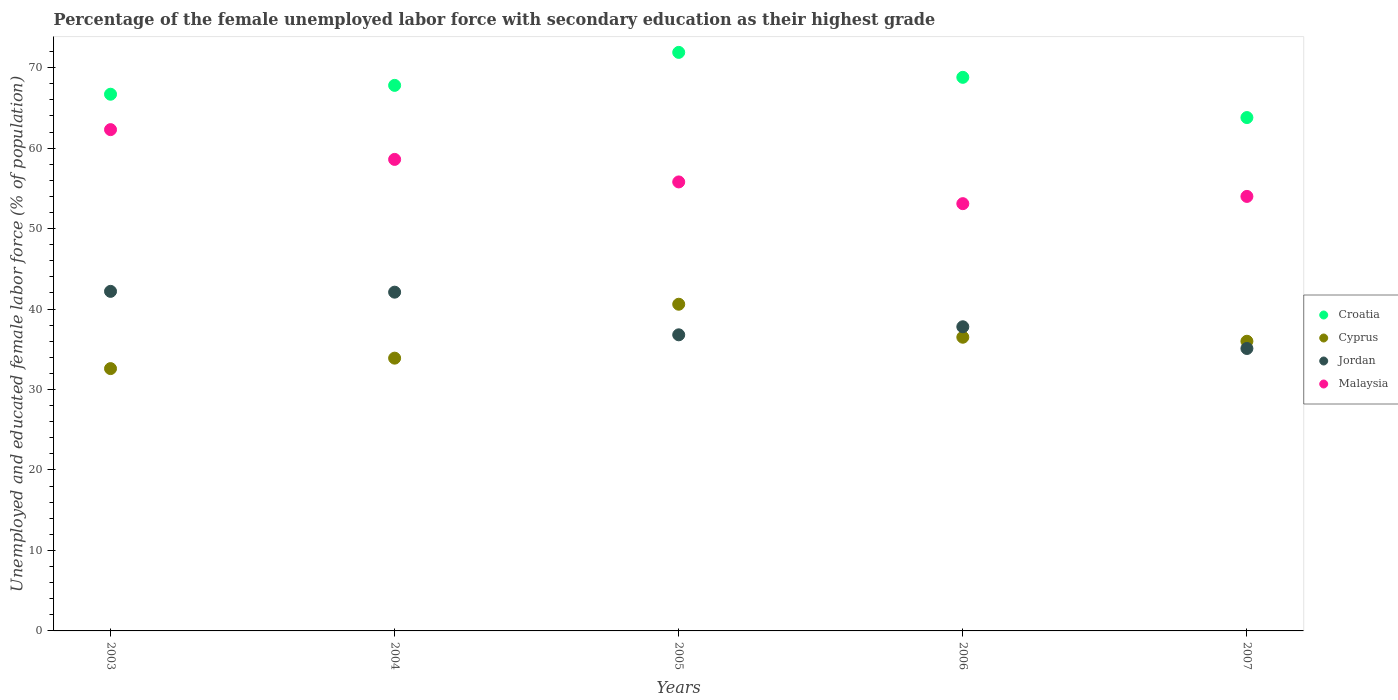Is the number of dotlines equal to the number of legend labels?
Provide a succinct answer. Yes. What is the percentage of the unemployed female labor force with secondary education in Cyprus in 2007?
Provide a succinct answer. 36. Across all years, what is the maximum percentage of the unemployed female labor force with secondary education in Cyprus?
Your response must be concise. 40.6. Across all years, what is the minimum percentage of the unemployed female labor force with secondary education in Jordan?
Give a very brief answer. 35.1. In which year was the percentage of the unemployed female labor force with secondary education in Malaysia minimum?
Provide a succinct answer. 2006. What is the total percentage of the unemployed female labor force with secondary education in Malaysia in the graph?
Provide a succinct answer. 283.8. What is the difference between the percentage of the unemployed female labor force with secondary education in Croatia in 2004 and that in 2005?
Your answer should be very brief. -4.1. What is the difference between the percentage of the unemployed female labor force with secondary education in Malaysia in 2006 and the percentage of the unemployed female labor force with secondary education in Jordan in 2005?
Provide a succinct answer. 16.3. What is the average percentage of the unemployed female labor force with secondary education in Malaysia per year?
Offer a very short reply. 56.76. In the year 2004, what is the difference between the percentage of the unemployed female labor force with secondary education in Malaysia and percentage of the unemployed female labor force with secondary education in Croatia?
Offer a terse response. -9.2. What is the ratio of the percentage of the unemployed female labor force with secondary education in Cyprus in 2003 to that in 2005?
Offer a terse response. 0.8. What is the difference between the highest and the second highest percentage of the unemployed female labor force with secondary education in Cyprus?
Make the answer very short. 4.1. What is the difference between the highest and the lowest percentage of the unemployed female labor force with secondary education in Jordan?
Provide a short and direct response. 7.1. In how many years, is the percentage of the unemployed female labor force with secondary education in Malaysia greater than the average percentage of the unemployed female labor force with secondary education in Malaysia taken over all years?
Your answer should be very brief. 2. Is the sum of the percentage of the unemployed female labor force with secondary education in Cyprus in 2003 and 2005 greater than the maximum percentage of the unemployed female labor force with secondary education in Croatia across all years?
Offer a terse response. Yes. Is it the case that in every year, the sum of the percentage of the unemployed female labor force with secondary education in Jordan and percentage of the unemployed female labor force with secondary education in Malaysia  is greater than the sum of percentage of the unemployed female labor force with secondary education in Cyprus and percentage of the unemployed female labor force with secondary education in Croatia?
Your answer should be compact. No. Is it the case that in every year, the sum of the percentage of the unemployed female labor force with secondary education in Malaysia and percentage of the unemployed female labor force with secondary education in Cyprus  is greater than the percentage of the unemployed female labor force with secondary education in Croatia?
Offer a terse response. Yes. Does the percentage of the unemployed female labor force with secondary education in Croatia monotonically increase over the years?
Ensure brevity in your answer.  No. Is the percentage of the unemployed female labor force with secondary education in Jordan strictly greater than the percentage of the unemployed female labor force with secondary education in Malaysia over the years?
Your response must be concise. No. Is the percentage of the unemployed female labor force with secondary education in Malaysia strictly less than the percentage of the unemployed female labor force with secondary education in Cyprus over the years?
Offer a very short reply. No. How many dotlines are there?
Offer a very short reply. 4. What is the difference between two consecutive major ticks on the Y-axis?
Your answer should be compact. 10. Does the graph contain any zero values?
Offer a very short reply. No. Does the graph contain grids?
Provide a short and direct response. No. Where does the legend appear in the graph?
Give a very brief answer. Center right. How are the legend labels stacked?
Offer a very short reply. Vertical. What is the title of the graph?
Ensure brevity in your answer.  Percentage of the female unemployed labor force with secondary education as their highest grade. What is the label or title of the X-axis?
Ensure brevity in your answer.  Years. What is the label or title of the Y-axis?
Ensure brevity in your answer.  Unemployed and educated female labor force (% of population). What is the Unemployed and educated female labor force (% of population) in Croatia in 2003?
Your answer should be very brief. 66.7. What is the Unemployed and educated female labor force (% of population) of Cyprus in 2003?
Provide a short and direct response. 32.6. What is the Unemployed and educated female labor force (% of population) of Jordan in 2003?
Offer a terse response. 42.2. What is the Unemployed and educated female labor force (% of population) of Malaysia in 2003?
Offer a terse response. 62.3. What is the Unemployed and educated female labor force (% of population) in Croatia in 2004?
Your answer should be very brief. 67.8. What is the Unemployed and educated female labor force (% of population) in Cyprus in 2004?
Your answer should be compact. 33.9. What is the Unemployed and educated female labor force (% of population) in Jordan in 2004?
Your response must be concise. 42.1. What is the Unemployed and educated female labor force (% of population) of Malaysia in 2004?
Offer a very short reply. 58.6. What is the Unemployed and educated female labor force (% of population) of Croatia in 2005?
Ensure brevity in your answer.  71.9. What is the Unemployed and educated female labor force (% of population) in Cyprus in 2005?
Your answer should be compact. 40.6. What is the Unemployed and educated female labor force (% of population) of Jordan in 2005?
Offer a terse response. 36.8. What is the Unemployed and educated female labor force (% of population) of Malaysia in 2005?
Give a very brief answer. 55.8. What is the Unemployed and educated female labor force (% of population) in Croatia in 2006?
Your answer should be compact. 68.8. What is the Unemployed and educated female labor force (% of population) of Cyprus in 2006?
Make the answer very short. 36.5. What is the Unemployed and educated female labor force (% of population) of Jordan in 2006?
Offer a very short reply. 37.8. What is the Unemployed and educated female labor force (% of population) of Malaysia in 2006?
Ensure brevity in your answer.  53.1. What is the Unemployed and educated female labor force (% of population) of Croatia in 2007?
Ensure brevity in your answer.  63.8. What is the Unemployed and educated female labor force (% of population) in Cyprus in 2007?
Provide a succinct answer. 36. What is the Unemployed and educated female labor force (% of population) in Jordan in 2007?
Provide a succinct answer. 35.1. Across all years, what is the maximum Unemployed and educated female labor force (% of population) of Croatia?
Give a very brief answer. 71.9. Across all years, what is the maximum Unemployed and educated female labor force (% of population) of Cyprus?
Offer a terse response. 40.6. Across all years, what is the maximum Unemployed and educated female labor force (% of population) of Jordan?
Provide a short and direct response. 42.2. Across all years, what is the maximum Unemployed and educated female labor force (% of population) of Malaysia?
Your response must be concise. 62.3. Across all years, what is the minimum Unemployed and educated female labor force (% of population) in Croatia?
Make the answer very short. 63.8. Across all years, what is the minimum Unemployed and educated female labor force (% of population) in Cyprus?
Give a very brief answer. 32.6. Across all years, what is the minimum Unemployed and educated female labor force (% of population) of Jordan?
Ensure brevity in your answer.  35.1. Across all years, what is the minimum Unemployed and educated female labor force (% of population) in Malaysia?
Offer a very short reply. 53.1. What is the total Unemployed and educated female labor force (% of population) in Croatia in the graph?
Provide a succinct answer. 339. What is the total Unemployed and educated female labor force (% of population) of Cyprus in the graph?
Provide a short and direct response. 179.6. What is the total Unemployed and educated female labor force (% of population) of Jordan in the graph?
Keep it short and to the point. 194. What is the total Unemployed and educated female labor force (% of population) in Malaysia in the graph?
Ensure brevity in your answer.  283.8. What is the difference between the Unemployed and educated female labor force (% of population) of Cyprus in 2003 and that in 2004?
Your answer should be compact. -1.3. What is the difference between the Unemployed and educated female labor force (% of population) of Jordan in 2003 and that in 2004?
Give a very brief answer. 0.1. What is the difference between the Unemployed and educated female labor force (% of population) in Cyprus in 2003 and that in 2005?
Your response must be concise. -8. What is the difference between the Unemployed and educated female labor force (% of population) in Jordan in 2003 and that in 2005?
Make the answer very short. 5.4. What is the difference between the Unemployed and educated female labor force (% of population) in Malaysia in 2003 and that in 2005?
Keep it short and to the point. 6.5. What is the difference between the Unemployed and educated female labor force (% of population) of Cyprus in 2003 and that in 2006?
Your answer should be very brief. -3.9. What is the difference between the Unemployed and educated female labor force (% of population) in Jordan in 2003 and that in 2006?
Keep it short and to the point. 4.4. What is the difference between the Unemployed and educated female labor force (% of population) in Malaysia in 2003 and that in 2006?
Provide a short and direct response. 9.2. What is the difference between the Unemployed and educated female labor force (% of population) in Cyprus in 2003 and that in 2007?
Keep it short and to the point. -3.4. What is the difference between the Unemployed and educated female labor force (% of population) in Cyprus in 2004 and that in 2005?
Offer a terse response. -6.7. What is the difference between the Unemployed and educated female labor force (% of population) of Jordan in 2004 and that in 2005?
Make the answer very short. 5.3. What is the difference between the Unemployed and educated female labor force (% of population) in Croatia in 2004 and that in 2006?
Ensure brevity in your answer.  -1. What is the difference between the Unemployed and educated female labor force (% of population) of Cyprus in 2004 and that in 2006?
Your answer should be very brief. -2.6. What is the difference between the Unemployed and educated female labor force (% of population) in Jordan in 2004 and that in 2006?
Ensure brevity in your answer.  4.3. What is the difference between the Unemployed and educated female labor force (% of population) in Jordan in 2004 and that in 2007?
Your answer should be very brief. 7. What is the difference between the Unemployed and educated female labor force (% of population) of Malaysia in 2004 and that in 2007?
Give a very brief answer. 4.6. What is the difference between the Unemployed and educated female labor force (% of population) in Croatia in 2005 and that in 2006?
Your response must be concise. 3.1. What is the difference between the Unemployed and educated female labor force (% of population) in Cyprus in 2005 and that in 2006?
Ensure brevity in your answer.  4.1. What is the difference between the Unemployed and educated female labor force (% of population) of Jordan in 2005 and that in 2006?
Keep it short and to the point. -1. What is the difference between the Unemployed and educated female labor force (% of population) in Croatia in 2005 and that in 2007?
Your answer should be compact. 8.1. What is the difference between the Unemployed and educated female labor force (% of population) of Cyprus in 2005 and that in 2007?
Give a very brief answer. 4.6. What is the difference between the Unemployed and educated female labor force (% of population) in Jordan in 2005 and that in 2007?
Offer a very short reply. 1.7. What is the difference between the Unemployed and educated female labor force (% of population) of Jordan in 2006 and that in 2007?
Provide a short and direct response. 2.7. What is the difference between the Unemployed and educated female labor force (% of population) in Croatia in 2003 and the Unemployed and educated female labor force (% of population) in Cyprus in 2004?
Provide a short and direct response. 32.8. What is the difference between the Unemployed and educated female labor force (% of population) of Croatia in 2003 and the Unemployed and educated female labor force (% of population) of Jordan in 2004?
Provide a succinct answer. 24.6. What is the difference between the Unemployed and educated female labor force (% of population) in Cyprus in 2003 and the Unemployed and educated female labor force (% of population) in Jordan in 2004?
Ensure brevity in your answer.  -9.5. What is the difference between the Unemployed and educated female labor force (% of population) in Cyprus in 2003 and the Unemployed and educated female labor force (% of population) in Malaysia in 2004?
Give a very brief answer. -26. What is the difference between the Unemployed and educated female labor force (% of population) of Jordan in 2003 and the Unemployed and educated female labor force (% of population) of Malaysia in 2004?
Ensure brevity in your answer.  -16.4. What is the difference between the Unemployed and educated female labor force (% of population) in Croatia in 2003 and the Unemployed and educated female labor force (% of population) in Cyprus in 2005?
Provide a short and direct response. 26.1. What is the difference between the Unemployed and educated female labor force (% of population) of Croatia in 2003 and the Unemployed and educated female labor force (% of population) of Jordan in 2005?
Provide a short and direct response. 29.9. What is the difference between the Unemployed and educated female labor force (% of population) of Cyprus in 2003 and the Unemployed and educated female labor force (% of population) of Malaysia in 2005?
Provide a succinct answer. -23.2. What is the difference between the Unemployed and educated female labor force (% of population) of Croatia in 2003 and the Unemployed and educated female labor force (% of population) of Cyprus in 2006?
Your answer should be compact. 30.2. What is the difference between the Unemployed and educated female labor force (% of population) in Croatia in 2003 and the Unemployed and educated female labor force (% of population) in Jordan in 2006?
Your answer should be compact. 28.9. What is the difference between the Unemployed and educated female labor force (% of population) of Cyprus in 2003 and the Unemployed and educated female labor force (% of population) of Jordan in 2006?
Give a very brief answer. -5.2. What is the difference between the Unemployed and educated female labor force (% of population) in Cyprus in 2003 and the Unemployed and educated female labor force (% of population) in Malaysia in 2006?
Provide a succinct answer. -20.5. What is the difference between the Unemployed and educated female labor force (% of population) in Jordan in 2003 and the Unemployed and educated female labor force (% of population) in Malaysia in 2006?
Offer a terse response. -10.9. What is the difference between the Unemployed and educated female labor force (% of population) of Croatia in 2003 and the Unemployed and educated female labor force (% of population) of Cyprus in 2007?
Provide a short and direct response. 30.7. What is the difference between the Unemployed and educated female labor force (% of population) of Croatia in 2003 and the Unemployed and educated female labor force (% of population) of Jordan in 2007?
Provide a succinct answer. 31.6. What is the difference between the Unemployed and educated female labor force (% of population) in Cyprus in 2003 and the Unemployed and educated female labor force (% of population) in Malaysia in 2007?
Ensure brevity in your answer.  -21.4. What is the difference between the Unemployed and educated female labor force (% of population) in Jordan in 2003 and the Unemployed and educated female labor force (% of population) in Malaysia in 2007?
Make the answer very short. -11.8. What is the difference between the Unemployed and educated female labor force (% of population) of Croatia in 2004 and the Unemployed and educated female labor force (% of population) of Cyprus in 2005?
Make the answer very short. 27.2. What is the difference between the Unemployed and educated female labor force (% of population) of Croatia in 2004 and the Unemployed and educated female labor force (% of population) of Jordan in 2005?
Provide a short and direct response. 31. What is the difference between the Unemployed and educated female labor force (% of population) of Croatia in 2004 and the Unemployed and educated female labor force (% of population) of Malaysia in 2005?
Offer a very short reply. 12. What is the difference between the Unemployed and educated female labor force (% of population) in Cyprus in 2004 and the Unemployed and educated female labor force (% of population) in Malaysia in 2005?
Offer a very short reply. -21.9. What is the difference between the Unemployed and educated female labor force (% of population) of Jordan in 2004 and the Unemployed and educated female labor force (% of population) of Malaysia in 2005?
Provide a succinct answer. -13.7. What is the difference between the Unemployed and educated female labor force (% of population) of Croatia in 2004 and the Unemployed and educated female labor force (% of population) of Cyprus in 2006?
Your answer should be very brief. 31.3. What is the difference between the Unemployed and educated female labor force (% of population) in Croatia in 2004 and the Unemployed and educated female labor force (% of population) in Malaysia in 2006?
Give a very brief answer. 14.7. What is the difference between the Unemployed and educated female labor force (% of population) of Cyprus in 2004 and the Unemployed and educated female labor force (% of population) of Malaysia in 2006?
Ensure brevity in your answer.  -19.2. What is the difference between the Unemployed and educated female labor force (% of population) of Croatia in 2004 and the Unemployed and educated female labor force (% of population) of Cyprus in 2007?
Your response must be concise. 31.8. What is the difference between the Unemployed and educated female labor force (% of population) in Croatia in 2004 and the Unemployed and educated female labor force (% of population) in Jordan in 2007?
Give a very brief answer. 32.7. What is the difference between the Unemployed and educated female labor force (% of population) of Cyprus in 2004 and the Unemployed and educated female labor force (% of population) of Malaysia in 2007?
Your answer should be very brief. -20.1. What is the difference between the Unemployed and educated female labor force (% of population) of Croatia in 2005 and the Unemployed and educated female labor force (% of population) of Cyprus in 2006?
Offer a terse response. 35.4. What is the difference between the Unemployed and educated female labor force (% of population) of Croatia in 2005 and the Unemployed and educated female labor force (% of population) of Jordan in 2006?
Your answer should be compact. 34.1. What is the difference between the Unemployed and educated female labor force (% of population) in Jordan in 2005 and the Unemployed and educated female labor force (% of population) in Malaysia in 2006?
Your answer should be compact. -16.3. What is the difference between the Unemployed and educated female labor force (% of population) of Croatia in 2005 and the Unemployed and educated female labor force (% of population) of Cyprus in 2007?
Provide a short and direct response. 35.9. What is the difference between the Unemployed and educated female labor force (% of population) of Croatia in 2005 and the Unemployed and educated female labor force (% of population) of Jordan in 2007?
Your response must be concise. 36.8. What is the difference between the Unemployed and educated female labor force (% of population) in Croatia in 2005 and the Unemployed and educated female labor force (% of population) in Malaysia in 2007?
Provide a succinct answer. 17.9. What is the difference between the Unemployed and educated female labor force (% of population) of Cyprus in 2005 and the Unemployed and educated female labor force (% of population) of Jordan in 2007?
Your answer should be very brief. 5.5. What is the difference between the Unemployed and educated female labor force (% of population) in Cyprus in 2005 and the Unemployed and educated female labor force (% of population) in Malaysia in 2007?
Provide a short and direct response. -13.4. What is the difference between the Unemployed and educated female labor force (% of population) in Jordan in 2005 and the Unemployed and educated female labor force (% of population) in Malaysia in 2007?
Give a very brief answer. -17.2. What is the difference between the Unemployed and educated female labor force (% of population) of Croatia in 2006 and the Unemployed and educated female labor force (% of population) of Cyprus in 2007?
Your response must be concise. 32.8. What is the difference between the Unemployed and educated female labor force (% of population) of Croatia in 2006 and the Unemployed and educated female labor force (% of population) of Jordan in 2007?
Ensure brevity in your answer.  33.7. What is the difference between the Unemployed and educated female labor force (% of population) of Croatia in 2006 and the Unemployed and educated female labor force (% of population) of Malaysia in 2007?
Your response must be concise. 14.8. What is the difference between the Unemployed and educated female labor force (% of population) of Cyprus in 2006 and the Unemployed and educated female labor force (% of population) of Malaysia in 2007?
Offer a very short reply. -17.5. What is the difference between the Unemployed and educated female labor force (% of population) of Jordan in 2006 and the Unemployed and educated female labor force (% of population) of Malaysia in 2007?
Your answer should be compact. -16.2. What is the average Unemployed and educated female labor force (% of population) of Croatia per year?
Give a very brief answer. 67.8. What is the average Unemployed and educated female labor force (% of population) in Cyprus per year?
Give a very brief answer. 35.92. What is the average Unemployed and educated female labor force (% of population) of Jordan per year?
Offer a very short reply. 38.8. What is the average Unemployed and educated female labor force (% of population) of Malaysia per year?
Provide a short and direct response. 56.76. In the year 2003, what is the difference between the Unemployed and educated female labor force (% of population) of Croatia and Unemployed and educated female labor force (% of population) of Cyprus?
Provide a short and direct response. 34.1. In the year 2003, what is the difference between the Unemployed and educated female labor force (% of population) in Croatia and Unemployed and educated female labor force (% of population) in Jordan?
Offer a very short reply. 24.5. In the year 2003, what is the difference between the Unemployed and educated female labor force (% of population) in Croatia and Unemployed and educated female labor force (% of population) in Malaysia?
Your answer should be very brief. 4.4. In the year 2003, what is the difference between the Unemployed and educated female labor force (% of population) in Cyprus and Unemployed and educated female labor force (% of population) in Malaysia?
Ensure brevity in your answer.  -29.7. In the year 2003, what is the difference between the Unemployed and educated female labor force (% of population) of Jordan and Unemployed and educated female labor force (% of population) of Malaysia?
Provide a succinct answer. -20.1. In the year 2004, what is the difference between the Unemployed and educated female labor force (% of population) of Croatia and Unemployed and educated female labor force (% of population) of Cyprus?
Keep it short and to the point. 33.9. In the year 2004, what is the difference between the Unemployed and educated female labor force (% of population) of Croatia and Unemployed and educated female labor force (% of population) of Jordan?
Provide a succinct answer. 25.7. In the year 2004, what is the difference between the Unemployed and educated female labor force (% of population) of Croatia and Unemployed and educated female labor force (% of population) of Malaysia?
Offer a very short reply. 9.2. In the year 2004, what is the difference between the Unemployed and educated female labor force (% of population) in Cyprus and Unemployed and educated female labor force (% of population) in Jordan?
Your response must be concise. -8.2. In the year 2004, what is the difference between the Unemployed and educated female labor force (% of population) in Cyprus and Unemployed and educated female labor force (% of population) in Malaysia?
Provide a succinct answer. -24.7. In the year 2004, what is the difference between the Unemployed and educated female labor force (% of population) of Jordan and Unemployed and educated female labor force (% of population) of Malaysia?
Ensure brevity in your answer.  -16.5. In the year 2005, what is the difference between the Unemployed and educated female labor force (% of population) in Croatia and Unemployed and educated female labor force (% of population) in Cyprus?
Offer a terse response. 31.3. In the year 2005, what is the difference between the Unemployed and educated female labor force (% of population) of Croatia and Unemployed and educated female labor force (% of population) of Jordan?
Your answer should be very brief. 35.1. In the year 2005, what is the difference between the Unemployed and educated female labor force (% of population) in Croatia and Unemployed and educated female labor force (% of population) in Malaysia?
Give a very brief answer. 16.1. In the year 2005, what is the difference between the Unemployed and educated female labor force (% of population) of Cyprus and Unemployed and educated female labor force (% of population) of Malaysia?
Your answer should be very brief. -15.2. In the year 2006, what is the difference between the Unemployed and educated female labor force (% of population) of Croatia and Unemployed and educated female labor force (% of population) of Cyprus?
Offer a very short reply. 32.3. In the year 2006, what is the difference between the Unemployed and educated female labor force (% of population) in Croatia and Unemployed and educated female labor force (% of population) in Jordan?
Ensure brevity in your answer.  31. In the year 2006, what is the difference between the Unemployed and educated female labor force (% of population) of Cyprus and Unemployed and educated female labor force (% of population) of Jordan?
Offer a very short reply. -1.3. In the year 2006, what is the difference between the Unemployed and educated female labor force (% of population) in Cyprus and Unemployed and educated female labor force (% of population) in Malaysia?
Provide a succinct answer. -16.6. In the year 2006, what is the difference between the Unemployed and educated female labor force (% of population) in Jordan and Unemployed and educated female labor force (% of population) in Malaysia?
Your response must be concise. -15.3. In the year 2007, what is the difference between the Unemployed and educated female labor force (% of population) of Croatia and Unemployed and educated female labor force (% of population) of Cyprus?
Keep it short and to the point. 27.8. In the year 2007, what is the difference between the Unemployed and educated female labor force (% of population) of Croatia and Unemployed and educated female labor force (% of population) of Jordan?
Make the answer very short. 28.7. In the year 2007, what is the difference between the Unemployed and educated female labor force (% of population) of Croatia and Unemployed and educated female labor force (% of population) of Malaysia?
Your answer should be very brief. 9.8. In the year 2007, what is the difference between the Unemployed and educated female labor force (% of population) in Jordan and Unemployed and educated female labor force (% of population) in Malaysia?
Ensure brevity in your answer.  -18.9. What is the ratio of the Unemployed and educated female labor force (% of population) in Croatia in 2003 to that in 2004?
Keep it short and to the point. 0.98. What is the ratio of the Unemployed and educated female labor force (% of population) of Cyprus in 2003 to that in 2004?
Your response must be concise. 0.96. What is the ratio of the Unemployed and educated female labor force (% of population) of Jordan in 2003 to that in 2004?
Your answer should be compact. 1. What is the ratio of the Unemployed and educated female labor force (% of population) of Malaysia in 2003 to that in 2004?
Give a very brief answer. 1.06. What is the ratio of the Unemployed and educated female labor force (% of population) in Croatia in 2003 to that in 2005?
Your response must be concise. 0.93. What is the ratio of the Unemployed and educated female labor force (% of population) in Cyprus in 2003 to that in 2005?
Make the answer very short. 0.8. What is the ratio of the Unemployed and educated female labor force (% of population) in Jordan in 2003 to that in 2005?
Ensure brevity in your answer.  1.15. What is the ratio of the Unemployed and educated female labor force (% of population) in Malaysia in 2003 to that in 2005?
Your answer should be very brief. 1.12. What is the ratio of the Unemployed and educated female labor force (% of population) in Croatia in 2003 to that in 2006?
Your response must be concise. 0.97. What is the ratio of the Unemployed and educated female labor force (% of population) in Cyprus in 2003 to that in 2006?
Your answer should be very brief. 0.89. What is the ratio of the Unemployed and educated female labor force (% of population) in Jordan in 2003 to that in 2006?
Keep it short and to the point. 1.12. What is the ratio of the Unemployed and educated female labor force (% of population) in Malaysia in 2003 to that in 2006?
Provide a short and direct response. 1.17. What is the ratio of the Unemployed and educated female labor force (% of population) in Croatia in 2003 to that in 2007?
Give a very brief answer. 1.05. What is the ratio of the Unemployed and educated female labor force (% of population) of Cyprus in 2003 to that in 2007?
Your answer should be compact. 0.91. What is the ratio of the Unemployed and educated female labor force (% of population) of Jordan in 2003 to that in 2007?
Provide a succinct answer. 1.2. What is the ratio of the Unemployed and educated female labor force (% of population) in Malaysia in 2003 to that in 2007?
Provide a succinct answer. 1.15. What is the ratio of the Unemployed and educated female labor force (% of population) of Croatia in 2004 to that in 2005?
Your response must be concise. 0.94. What is the ratio of the Unemployed and educated female labor force (% of population) of Cyprus in 2004 to that in 2005?
Your response must be concise. 0.83. What is the ratio of the Unemployed and educated female labor force (% of population) in Jordan in 2004 to that in 2005?
Offer a terse response. 1.14. What is the ratio of the Unemployed and educated female labor force (% of population) in Malaysia in 2004 to that in 2005?
Your response must be concise. 1.05. What is the ratio of the Unemployed and educated female labor force (% of population) of Croatia in 2004 to that in 2006?
Offer a terse response. 0.99. What is the ratio of the Unemployed and educated female labor force (% of population) of Cyprus in 2004 to that in 2006?
Your response must be concise. 0.93. What is the ratio of the Unemployed and educated female labor force (% of population) of Jordan in 2004 to that in 2006?
Provide a succinct answer. 1.11. What is the ratio of the Unemployed and educated female labor force (% of population) of Malaysia in 2004 to that in 2006?
Your answer should be compact. 1.1. What is the ratio of the Unemployed and educated female labor force (% of population) in Croatia in 2004 to that in 2007?
Your answer should be compact. 1.06. What is the ratio of the Unemployed and educated female labor force (% of population) of Cyprus in 2004 to that in 2007?
Your answer should be compact. 0.94. What is the ratio of the Unemployed and educated female labor force (% of population) in Jordan in 2004 to that in 2007?
Your answer should be very brief. 1.2. What is the ratio of the Unemployed and educated female labor force (% of population) of Malaysia in 2004 to that in 2007?
Your response must be concise. 1.09. What is the ratio of the Unemployed and educated female labor force (% of population) of Croatia in 2005 to that in 2006?
Your answer should be compact. 1.05. What is the ratio of the Unemployed and educated female labor force (% of population) in Cyprus in 2005 to that in 2006?
Provide a short and direct response. 1.11. What is the ratio of the Unemployed and educated female labor force (% of population) in Jordan in 2005 to that in 2006?
Offer a very short reply. 0.97. What is the ratio of the Unemployed and educated female labor force (% of population) in Malaysia in 2005 to that in 2006?
Provide a succinct answer. 1.05. What is the ratio of the Unemployed and educated female labor force (% of population) in Croatia in 2005 to that in 2007?
Offer a terse response. 1.13. What is the ratio of the Unemployed and educated female labor force (% of population) in Cyprus in 2005 to that in 2007?
Keep it short and to the point. 1.13. What is the ratio of the Unemployed and educated female labor force (% of population) of Jordan in 2005 to that in 2007?
Your answer should be compact. 1.05. What is the ratio of the Unemployed and educated female labor force (% of population) in Croatia in 2006 to that in 2007?
Give a very brief answer. 1.08. What is the ratio of the Unemployed and educated female labor force (% of population) in Cyprus in 2006 to that in 2007?
Keep it short and to the point. 1.01. What is the ratio of the Unemployed and educated female labor force (% of population) in Jordan in 2006 to that in 2007?
Provide a succinct answer. 1.08. What is the ratio of the Unemployed and educated female labor force (% of population) of Malaysia in 2006 to that in 2007?
Your answer should be very brief. 0.98. What is the difference between the highest and the second highest Unemployed and educated female labor force (% of population) of Croatia?
Your response must be concise. 3.1. What is the difference between the highest and the second highest Unemployed and educated female labor force (% of population) in Cyprus?
Keep it short and to the point. 4.1. What is the difference between the highest and the lowest Unemployed and educated female labor force (% of population) of Croatia?
Your response must be concise. 8.1. 